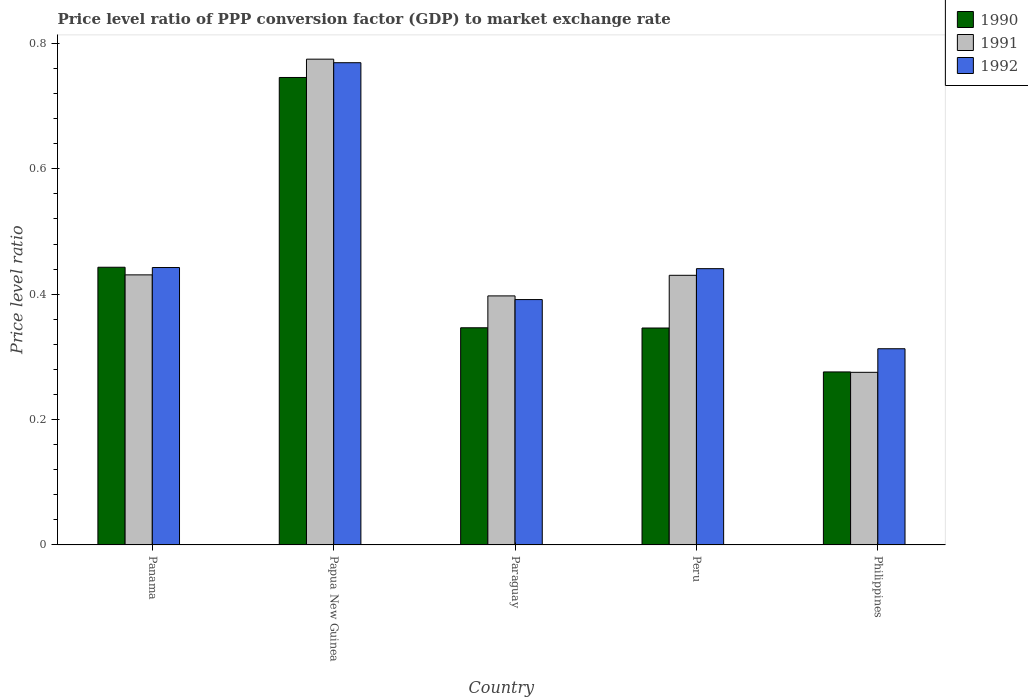How many different coloured bars are there?
Provide a short and direct response. 3. How many groups of bars are there?
Your answer should be very brief. 5. How many bars are there on the 3rd tick from the left?
Your answer should be compact. 3. How many bars are there on the 1st tick from the right?
Offer a terse response. 3. What is the label of the 3rd group of bars from the left?
Offer a very short reply. Paraguay. In how many cases, is the number of bars for a given country not equal to the number of legend labels?
Your response must be concise. 0. What is the price level ratio in 1991 in Papua New Guinea?
Your response must be concise. 0.77. Across all countries, what is the maximum price level ratio in 1990?
Your response must be concise. 0.75. Across all countries, what is the minimum price level ratio in 1992?
Your answer should be compact. 0.31. In which country was the price level ratio in 1992 maximum?
Your response must be concise. Papua New Guinea. What is the total price level ratio in 1990 in the graph?
Offer a terse response. 2.16. What is the difference between the price level ratio in 1992 in Paraguay and that in Peru?
Provide a succinct answer. -0.05. What is the difference between the price level ratio in 1991 in Philippines and the price level ratio in 1990 in Paraguay?
Your answer should be compact. -0.07. What is the average price level ratio in 1991 per country?
Keep it short and to the point. 0.46. What is the difference between the price level ratio of/in 1991 and price level ratio of/in 1990 in Papua New Guinea?
Make the answer very short. 0.03. In how many countries, is the price level ratio in 1990 greater than 0.7200000000000001?
Make the answer very short. 1. What is the ratio of the price level ratio in 1990 in Paraguay to that in Philippines?
Give a very brief answer. 1.26. Is the price level ratio in 1990 in Papua New Guinea less than that in Philippines?
Make the answer very short. No. What is the difference between the highest and the second highest price level ratio in 1990?
Offer a very short reply. 0.3. What is the difference between the highest and the lowest price level ratio in 1992?
Provide a succinct answer. 0.46. In how many countries, is the price level ratio in 1992 greater than the average price level ratio in 1992 taken over all countries?
Your answer should be compact. 1. Is the sum of the price level ratio in 1990 in Panama and Peru greater than the maximum price level ratio in 1991 across all countries?
Your answer should be very brief. Yes. What does the 2nd bar from the right in Papua New Guinea represents?
Provide a short and direct response. 1991. Is it the case that in every country, the sum of the price level ratio in 1991 and price level ratio in 1992 is greater than the price level ratio in 1990?
Your response must be concise. Yes. How many bars are there?
Your answer should be very brief. 15. Are the values on the major ticks of Y-axis written in scientific E-notation?
Ensure brevity in your answer.  No. Does the graph contain any zero values?
Your answer should be compact. No. How many legend labels are there?
Keep it short and to the point. 3. How are the legend labels stacked?
Offer a terse response. Vertical. What is the title of the graph?
Your response must be concise. Price level ratio of PPP conversion factor (GDP) to market exchange rate. What is the label or title of the X-axis?
Keep it short and to the point. Country. What is the label or title of the Y-axis?
Give a very brief answer. Price level ratio. What is the Price level ratio in 1990 in Panama?
Offer a terse response. 0.44. What is the Price level ratio in 1991 in Panama?
Give a very brief answer. 0.43. What is the Price level ratio of 1992 in Panama?
Give a very brief answer. 0.44. What is the Price level ratio of 1990 in Papua New Guinea?
Keep it short and to the point. 0.75. What is the Price level ratio in 1991 in Papua New Guinea?
Ensure brevity in your answer.  0.77. What is the Price level ratio in 1992 in Papua New Guinea?
Keep it short and to the point. 0.77. What is the Price level ratio in 1990 in Paraguay?
Make the answer very short. 0.35. What is the Price level ratio of 1991 in Paraguay?
Provide a short and direct response. 0.4. What is the Price level ratio of 1992 in Paraguay?
Give a very brief answer. 0.39. What is the Price level ratio in 1990 in Peru?
Keep it short and to the point. 0.35. What is the Price level ratio in 1991 in Peru?
Your answer should be very brief. 0.43. What is the Price level ratio in 1992 in Peru?
Provide a succinct answer. 0.44. What is the Price level ratio in 1990 in Philippines?
Your response must be concise. 0.28. What is the Price level ratio of 1991 in Philippines?
Offer a very short reply. 0.28. What is the Price level ratio of 1992 in Philippines?
Your response must be concise. 0.31. Across all countries, what is the maximum Price level ratio of 1990?
Your answer should be compact. 0.75. Across all countries, what is the maximum Price level ratio in 1991?
Ensure brevity in your answer.  0.77. Across all countries, what is the maximum Price level ratio of 1992?
Make the answer very short. 0.77. Across all countries, what is the minimum Price level ratio in 1990?
Give a very brief answer. 0.28. Across all countries, what is the minimum Price level ratio of 1991?
Give a very brief answer. 0.28. Across all countries, what is the minimum Price level ratio of 1992?
Provide a short and direct response. 0.31. What is the total Price level ratio of 1990 in the graph?
Offer a very short reply. 2.16. What is the total Price level ratio of 1991 in the graph?
Your answer should be compact. 2.31. What is the total Price level ratio in 1992 in the graph?
Your response must be concise. 2.36. What is the difference between the Price level ratio in 1990 in Panama and that in Papua New Guinea?
Give a very brief answer. -0.3. What is the difference between the Price level ratio of 1991 in Panama and that in Papua New Guinea?
Offer a very short reply. -0.34. What is the difference between the Price level ratio of 1992 in Panama and that in Papua New Guinea?
Your answer should be very brief. -0.33. What is the difference between the Price level ratio in 1990 in Panama and that in Paraguay?
Offer a terse response. 0.1. What is the difference between the Price level ratio in 1991 in Panama and that in Paraguay?
Your answer should be compact. 0.03. What is the difference between the Price level ratio in 1992 in Panama and that in Paraguay?
Your answer should be very brief. 0.05. What is the difference between the Price level ratio of 1990 in Panama and that in Peru?
Provide a short and direct response. 0.1. What is the difference between the Price level ratio in 1991 in Panama and that in Peru?
Your response must be concise. 0. What is the difference between the Price level ratio in 1992 in Panama and that in Peru?
Offer a terse response. 0. What is the difference between the Price level ratio in 1990 in Panama and that in Philippines?
Ensure brevity in your answer.  0.17. What is the difference between the Price level ratio in 1991 in Panama and that in Philippines?
Your answer should be very brief. 0.16. What is the difference between the Price level ratio in 1992 in Panama and that in Philippines?
Your answer should be compact. 0.13. What is the difference between the Price level ratio in 1990 in Papua New Guinea and that in Paraguay?
Offer a very short reply. 0.4. What is the difference between the Price level ratio of 1991 in Papua New Guinea and that in Paraguay?
Ensure brevity in your answer.  0.38. What is the difference between the Price level ratio of 1992 in Papua New Guinea and that in Paraguay?
Provide a succinct answer. 0.38. What is the difference between the Price level ratio in 1990 in Papua New Guinea and that in Peru?
Provide a succinct answer. 0.4. What is the difference between the Price level ratio in 1991 in Papua New Guinea and that in Peru?
Your response must be concise. 0.34. What is the difference between the Price level ratio of 1992 in Papua New Guinea and that in Peru?
Your answer should be compact. 0.33. What is the difference between the Price level ratio of 1990 in Papua New Guinea and that in Philippines?
Provide a succinct answer. 0.47. What is the difference between the Price level ratio in 1991 in Papua New Guinea and that in Philippines?
Your response must be concise. 0.5. What is the difference between the Price level ratio of 1992 in Papua New Guinea and that in Philippines?
Your answer should be compact. 0.46. What is the difference between the Price level ratio of 1991 in Paraguay and that in Peru?
Offer a terse response. -0.03. What is the difference between the Price level ratio of 1992 in Paraguay and that in Peru?
Offer a very short reply. -0.05. What is the difference between the Price level ratio of 1990 in Paraguay and that in Philippines?
Offer a terse response. 0.07. What is the difference between the Price level ratio of 1991 in Paraguay and that in Philippines?
Make the answer very short. 0.12. What is the difference between the Price level ratio in 1992 in Paraguay and that in Philippines?
Provide a succinct answer. 0.08. What is the difference between the Price level ratio of 1990 in Peru and that in Philippines?
Your response must be concise. 0.07. What is the difference between the Price level ratio in 1991 in Peru and that in Philippines?
Offer a terse response. 0.15. What is the difference between the Price level ratio in 1992 in Peru and that in Philippines?
Keep it short and to the point. 0.13. What is the difference between the Price level ratio in 1990 in Panama and the Price level ratio in 1991 in Papua New Guinea?
Give a very brief answer. -0.33. What is the difference between the Price level ratio of 1990 in Panama and the Price level ratio of 1992 in Papua New Guinea?
Provide a succinct answer. -0.33. What is the difference between the Price level ratio of 1991 in Panama and the Price level ratio of 1992 in Papua New Guinea?
Provide a succinct answer. -0.34. What is the difference between the Price level ratio of 1990 in Panama and the Price level ratio of 1991 in Paraguay?
Ensure brevity in your answer.  0.05. What is the difference between the Price level ratio in 1990 in Panama and the Price level ratio in 1992 in Paraguay?
Provide a short and direct response. 0.05. What is the difference between the Price level ratio of 1991 in Panama and the Price level ratio of 1992 in Paraguay?
Ensure brevity in your answer.  0.04. What is the difference between the Price level ratio in 1990 in Panama and the Price level ratio in 1991 in Peru?
Provide a succinct answer. 0.01. What is the difference between the Price level ratio of 1990 in Panama and the Price level ratio of 1992 in Peru?
Your response must be concise. 0. What is the difference between the Price level ratio of 1991 in Panama and the Price level ratio of 1992 in Peru?
Your answer should be very brief. -0.01. What is the difference between the Price level ratio of 1990 in Panama and the Price level ratio of 1991 in Philippines?
Keep it short and to the point. 0.17. What is the difference between the Price level ratio of 1990 in Panama and the Price level ratio of 1992 in Philippines?
Offer a very short reply. 0.13. What is the difference between the Price level ratio of 1991 in Panama and the Price level ratio of 1992 in Philippines?
Your response must be concise. 0.12. What is the difference between the Price level ratio of 1990 in Papua New Guinea and the Price level ratio of 1991 in Paraguay?
Offer a terse response. 0.35. What is the difference between the Price level ratio in 1990 in Papua New Guinea and the Price level ratio in 1992 in Paraguay?
Make the answer very short. 0.35. What is the difference between the Price level ratio in 1991 in Papua New Guinea and the Price level ratio in 1992 in Paraguay?
Your answer should be very brief. 0.38. What is the difference between the Price level ratio in 1990 in Papua New Guinea and the Price level ratio in 1991 in Peru?
Ensure brevity in your answer.  0.32. What is the difference between the Price level ratio in 1990 in Papua New Guinea and the Price level ratio in 1992 in Peru?
Make the answer very short. 0.3. What is the difference between the Price level ratio in 1991 in Papua New Guinea and the Price level ratio in 1992 in Peru?
Provide a short and direct response. 0.33. What is the difference between the Price level ratio of 1990 in Papua New Guinea and the Price level ratio of 1991 in Philippines?
Your response must be concise. 0.47. What is the difference between the Price level ratio in 1990 in Papua New Guinea and the Price level ratio in 1992 in Philippines?
Your response must be concise. 0.43. What is the difference between the Price level ratio in 1991 in Papua New Guinea and the Price level ratio in 1992 in Philippines?
Offer a very short reply. 0.46. What is the difference between the Price level ratio of 1990 in Paraguay and the Price level ratio of 1991 in Peru?
Your answer should be very brief. -0.08. What is the difference between the Price level ratio of 1990 in Paraguay and the Price level ratio of 1992 in Peru?
Offer a terse response. -0.09. What is the difference between the Price level ratio of 1991 in Paraguay and the Price level ratio of 1992 in Peru?
Your answer should be compact. -0.04. What is the difference between the Price level ratio of 1990 in Paraguay and the Price level ratio of 1991 in Philippines?
Make the answer very short. 0.07. What is the difference between the Price level ratio of 1990 in Paraguay and the Price level ratio of 1992 in Philippines?
Give a very brief answer. 0.03. What is the difference between the Price level ratio of 1991 in Paraguay and the Price level ratio of 1992 in Philippines?
Offer a very short reply. 0.08. What is the difference between the Price level ratio of 1990 in Peru and the Price level ratio of 1991 in Philippines?
Your answer should be compact. 0.07. What is the difference between the Price level ratio of 1990 in Peru and the Price level ratio of 1992 in Philippines?
Your response must be concise. 0.03. What is the difference between the Price level ratio of 1991 in Peru and the Price level ratio of 1992 in Philippines?
Offer a very short reply. 0.12. What is the average Price level ratio of 1990 per country?
Provide a succinct answer. 0.43. What is the average Price level ratio of 1991 per country?
Your answer should be compact. 0.46. What is the average Price level ratio in 1992 per country?
Your response must be concise. 0.47. What is the difference between the Price level ratio of 1990 and Price level ratio of 1991 in Panama?
Give a very brief answer. 0.01. What is the difference between the Price level ratio in 1991 and Price level ratio in 1992 in Panama?
Your answer should be compact. -0.01. What is the difference between the Price level ratio of 1990 and Price level ratio of 1991 in Papua New Guinea?
Ensure brevity in your answer.  -0.03. What is the difference between the Price level ratio of 1990 and Price level ratio of 1992 in Papua New Guinea?
Your answer should be compact. -0.02. What is the difference between the Price level ratio of 1991 and Price level ratio of 1992 in Papua New Guinea?
Your answer should be compact. 0.01. What is the difference between the Price level ratio in 1990 and Price level ratio in 1991 in Paraguay?
Your answer should be very brief. -0.05. What is the difference between the Price level ratio in 1990 and Price level ratio in 1992 in Paraguay?
Keep it short and to the point. -0.04. What is the difference between the Price level ratio in 1991 and Price level ratio in 1992 in Paraguay?
Your answer should be very brief. 0.01. What is the difference between the Price level ratio in 1990 and Price level ratio in 1991 in Peru?
Offer a very short reply. -0.08. What is the difference between the Price level ratio in 1990 and Price level ratio in 1992 in Peru?
Provide a short and direct response. -0.09. What is the difference between the Price level ratio in 1991 and Price level ratio in 1992 in Peru?
Your answer should be compact. -0.01. What is the difference between the Price level ratio of 1990 and Price level ratio of 1991 in Philippines?
Offer a very short reply. 0. What is the difference between the Price level ratio in 1990 and Price level ratio in 1992 in Philippines?
Give a very brief answer. -0.04. What is the difference between the Price level ratio in 1991 and Price level ratio in 1992 in Philippines?
Your response must be concise. -0.04. What is the ratio of the Price level ratio of 1990 in Panama to that in Papua New Guinea?
Offer a very short reply. 0.59. What is the ratio of the Price level ratio in 1991 in Panama to that in Papua New Guinea?
Offer a terse response. 0.56. What is the ratio of the Price level ratio of 1992 in Panama to that in Papua New Guinea?
Your answer should be very brief. 0.58. What is the ratio of the Price level ratio of 1990 in Panama to that in Paraguay?
Provide a succinct answer. 1.28. What is the ratio of the Price level ratio in 1991 in Panama to that in Paraguay?
Give a very brief answer. 1.08. What is the ratio of the Price level ratio in 1992 in Panama to that in Paraguay?
Your answer should be compact. 1.13. What is the ratio of the Price level ratio in 1990 in Panama to that in Peru?
Your answer should be compact. 1.28. What is the ratio of the Price level ratio of 1992 in Panama to that in Peru?
Your answer should be very brief. 1. What is the ratio of the Price level ratio of 1990 in Panama to that in Philippines?
Make the answer very short. 1.61. What is the ratio of the Price level ratio in 1991 in Panama to that in Philippines?
Offer a terse response. 1.56. What is the ratio of the Price level ratio in 1992 in Panama to that in Philippines?
Your response must be concise. 1.41. What is the ratio of the Price level ratio in 1990 in Papua New Guinea to that in Paraguay?
Your answer should be compact. 2.15. What is the ratio of the Price level ratio in 1991 in Papua New Guinea to that in Paraguay?
Provide a short and direct response. 1.95. What is the ratio of the Price level ratio of 1992 in Papua New Guinea to that in Paraguay?
Offer a terse response. 1.97. What is the ratio of the Price level ratio in 1990 in Papua New Guinea to that in Peru?
Offer a very short reply. 2.15. What is the ratio of the Price level ratio in 1991 in Papua New Guinea to that in Peru?
Give a very brief answer. 1.8. What is the ratio of the Price level ratio of 1992 in Papua New Guinea to that in Peru?
Offer a very short reply. 1.75. What is the ratio of the Price level ratio in 1990 in Papua New Guinea to that in Philippines?
Make the answer very short. 2.7. What is the ratio of the Price level ratio of 1991 in Papua New Guinea to that in Philippines?
Provide a succinct answer. 2.81. What is the ratio of the Price level ratio of 1992 in Papua New Guinea to that in Philippines?
Offer a terse response. 2.46. What is the ratio of the Price level ratio in 1991 in Paraguay to that in Peru?
Ensure brevity in your answer.  0.92. What is the ratio of the Price level ratio in 1992 in Paraguay to that in Peru?
Offer a terse response. 0.89. What is the ratio of the Price level ratio of 1990 in Paraguay to that in Philippines?
Provide a succinct answer. 1.26. What is the ratio of the Price level ratio in 1991 in Paraguay to that in Philippines?
Your response must be concise. 1.44. What is the ratio of the Price level ratio of 1992 in Paraguay to that in Philippines?
Offer a very short reply. 1.25. What is the ratio of the Price level ratio in 1990 in Peru to that in Philippines?
Your answer should be compact. 1.25. What is the ratio of the Price level ratio in 1991 in Peru to that in Philippines?
Ensure brevity in your answer.  1.56. What is the ratio of the Price level ratio of 1992 in Peru to that in Philippines?
Make the answer very short. 1.41. What is the difference between the highest and the second highest Price level ratio of 1990?
Offer a very short reply. 0.3. What is the difference between the highest and the second highest Price level ratio of 1991?
Your answer should be very brief. 0.34. What is the difference between the highest and the second highest Price level ratio of 1992?
Make the answer very short. 0.33. What is the difference between the highest and the lowest Price level ratio in 1990?
Provide a succinct answer. 0.47. What is the difference between the highest and the lowest Price level ratio in 1991?
Provide a succinct answer. 0.5. What is the difference between the highest and the lowest Price level ratio of 1992?
Offer a very short reply. 0.46. 